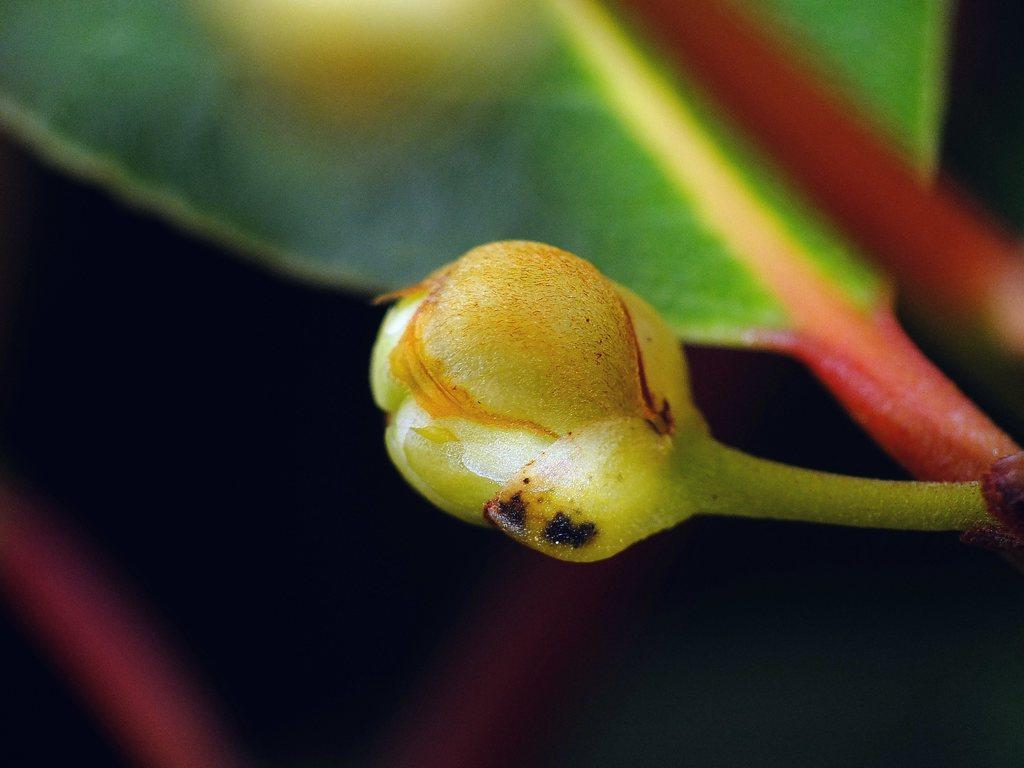What type of plant part can be seen in the image? There is a bud present in the image. What other part of the plant can be seen in the image? A leaf is present in the image. What type of snack is visible in the image? There is no snack present in the image; it only features a bud and a leaf. What is the edge of the image made of? The edge of the image is not visible in the image itself, as it is a digital representation. 